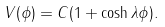Convert formula to latex. <formula><loc_0><loc_0><loc_500><loc_500>V ( \phi ) = C ( 1 + \cosh \lambda \phi ) .</formula> 